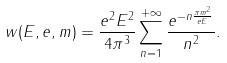<formula> <loc_0><loc_0><loc_500><loc_500>w ( E , e , m ) = \frac { e ^ { 2 } E ^ { 2 } } { 4 \pi ^ { 3 } } \sum _ { n = 1 } ^ { + \infty } \frac { e ^ { - n \frac { \pi m ^ { 2 } } { e E } } } { n ^ { 2 } } .</formula> 